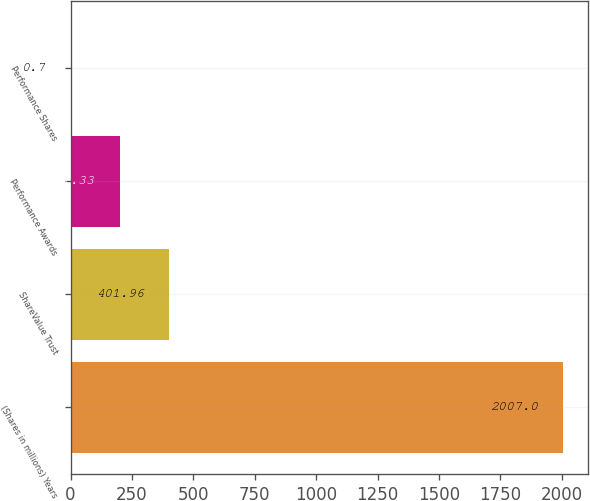<chart> <loc_0><loc_0><loc_500><loc_500><bar_chart><fcel>(Shares in millions) Years<fcel>ShareValue Trust<fcel>Performance Awards<fcel>Performance Shares<nl><fcel>2007<fcel>401.96<fcel>201.33<fcel>0.7<nl></chart> 